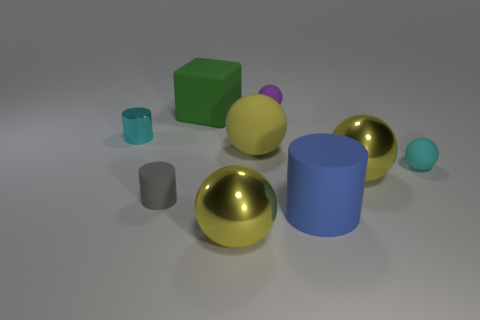What can you infer about the materials of the objects? The gold spheres, with their reflective surface, appear to be metallic, likely made of brass or a gold-plated material. The matte surface of the green cube and the violet sphere indicate a soft, rubber-like composition. The blue cylinder, with its solid but slightly less reflective surface, suggests a hard plastic. Finally, the small teal cylinder and the tiny turquoise sphere have a translucent quality, pointing to a glass or crystalline material. 